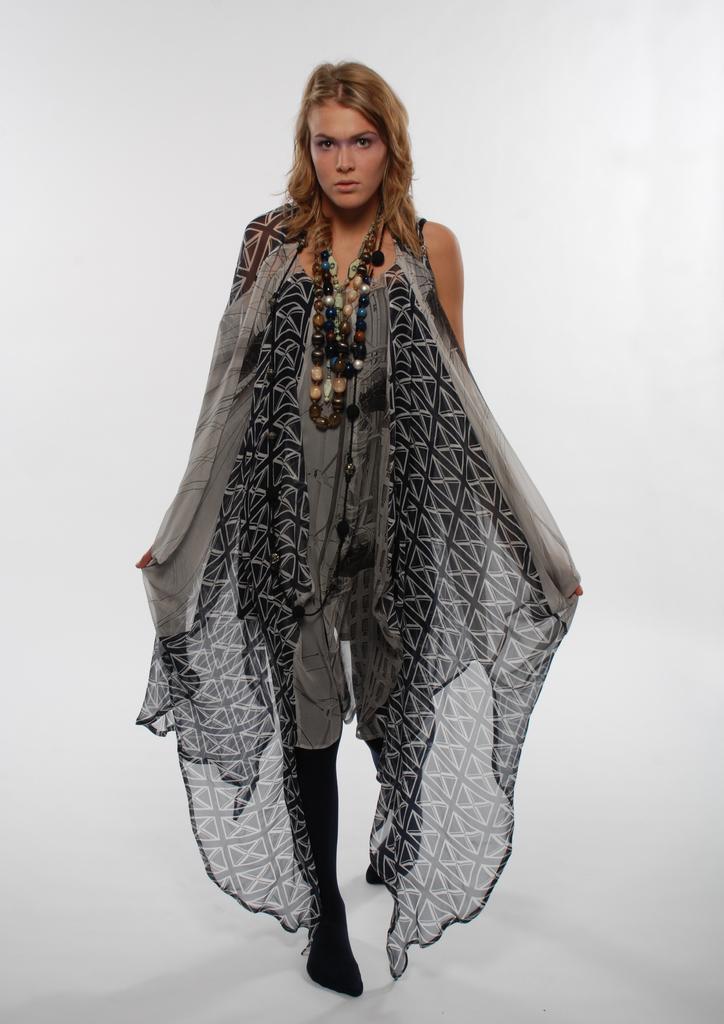Could you give a brief overview of what you see in this image? In the center of the image there is a woman standing on the floor. 